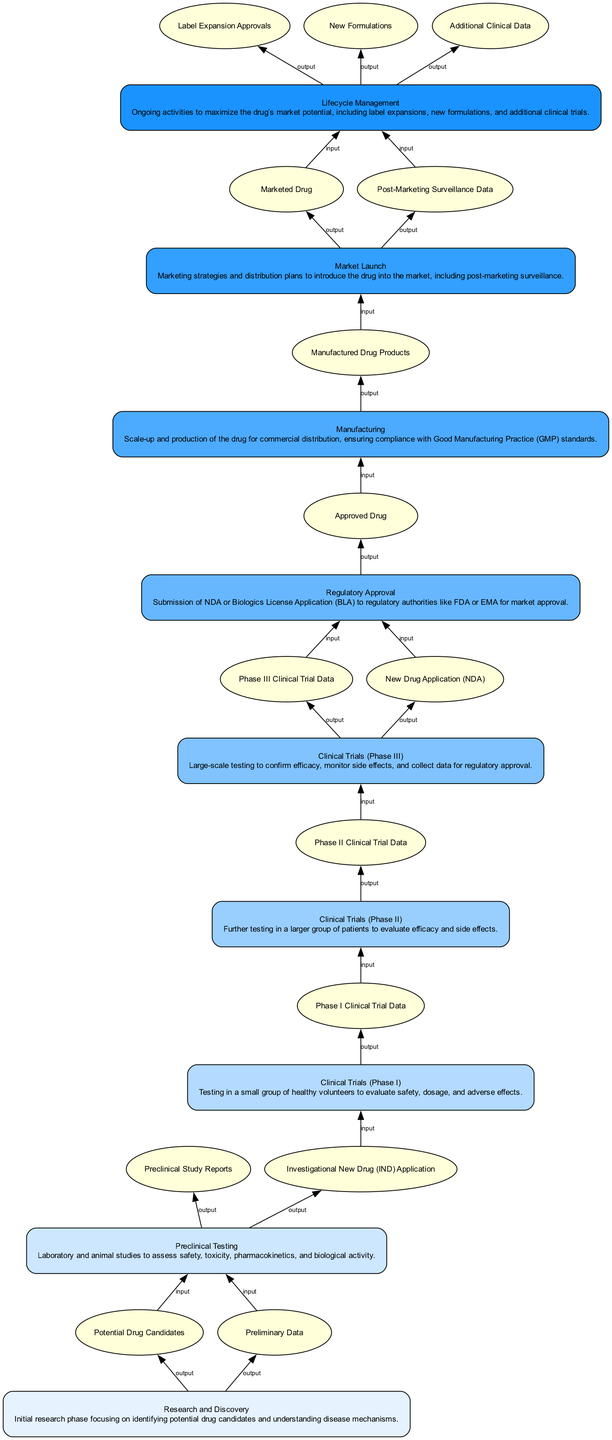What is the first stage in the product lifecycle management? The first stage listed in the diagram is "Research and Discovery". It is positioned at the bottom of the flowchart, indicating it's the starting point of the lifecycle.
Answer: Research and Discovery How many outputs does "Clinical Trials (Phase III)" produce? The element "Clinical Trials (Phase III)" has two outputs: "Phase III Clinical Trial Data" and "New Drug Application (NDA)". Counting these provides the answer.
Answer: 2 What is the final stage of the product lifecycle management process? The final stage is "Lifecycle Management", which is shown at the top of the flowchart, indicating it is the conclusion of the pathway.
Answer: Lifecycle Management Which element directly follows "Regulatory Approval" in the flow? The diagram indicates that "Manufacturing" follows "Regulatory Approval", as it has a direct connection from the previous stage.
Answer: Manufacturing What are the inputs required for "Clinical Trials (Phase II)"? The inputs for "Clinical Trials (Phase II)" are derived from the previous stage and they are "Phase I Clinical Trial Data". This step checks the inputs for that specific phase.
Answer: Phase I Clinical Trial Data How does "Market Launch" connect to "Manufacturing"? "Market Launch" is positioned above "Manufacturing" with an arrow indicating a direct flow of outputs. This signifies that "Market Launch" receives inputs from "Manufacturing" and represents the next step in the process.
Answer: With an output from Manufactured Drug Products What outputs are generated from the "Lifecycle Management" stage? The "Lifecycle Management" stage has three outputs listed: "Label Expansion Approvals", "New Formulations", and "Additional Clinical Data". Each output is noted under this stage in the flowchart.
Answer: Label Expansion Approvals, New Formulations, Additional Clinical Data How many stages are there from "Research and Discovery" to "Market Launch"? Starting at "Research and Discovery" and counting upward to "Market Launch", we find a total of seven distinct stages in the flowchart.
Answer: 7 What type of applications are submitted during "Regulatory Approval"? The applications that are submitted during "Regulatory Approval" include the "New Drug Application (NDA)" and "Biologics License Application (BLA)", which are both noted in this stage.
Answer: New Drug Application (NDA) and Biologics License Application (BLA) 